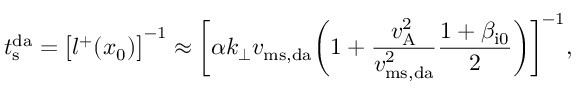<formula> <loc_0><loc_0><loc_500><loc_500>t _ { s } ^ { d a } = \left [ l ^ { + } ( x _ { 0 } ) \right ] ^ { - 1 } \approx \left [ \alpha k _ { \perp } v _ { m s , d a } \left ( 1 + \frac { v _ { A } ^ { 2 } } { v _ { m s , d a } ^ { 2 } } \frac { 1 + \beta _ { i 0 } } { 2 } \right ) \right ] ^ { - 1 } ,</formula> 